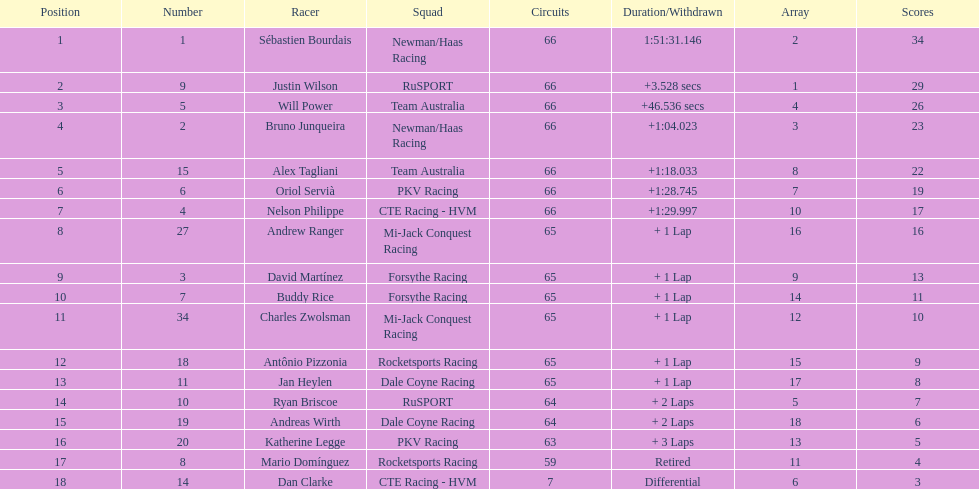Which country is represented by the most drivers? United Kingdom. 